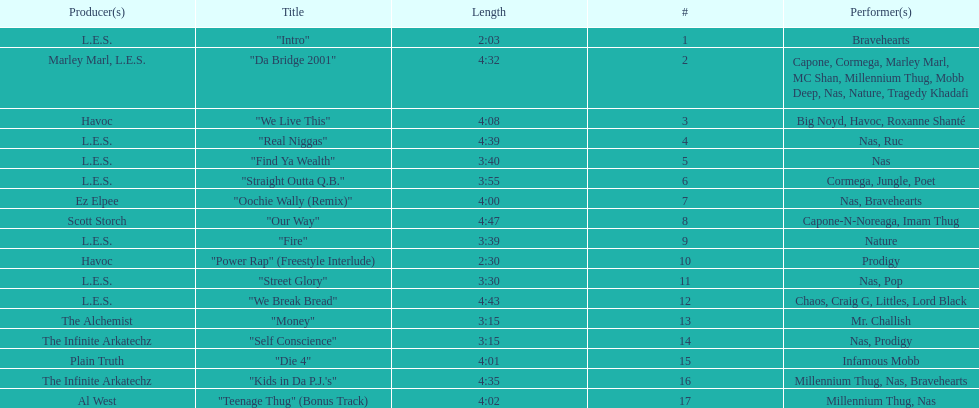What is the initial track on the album created by havoc? "We Live This". 